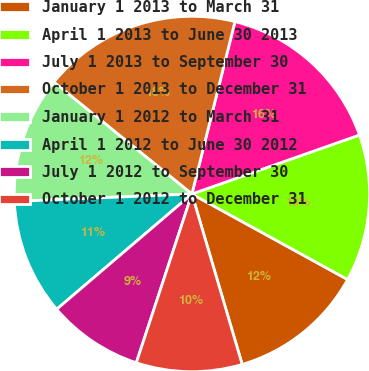Convert chart to OTSL. <chart><loc_0><loc_0><loc_500><loc_500><pie_chart><fcel>January 1 2013 to March 31<fcel>April 1 2013 to June 30 2013<fcel>July 1 2013 to September 30<fcel>October 1 2013 to December 31<fcel>January 1 2012 to March 31<fcel>April 1 2012 to June 30 2012<fcel>July 1 2012 to September 30<fcel>October 1 2012 to December 31<nl><fcel>12.44%<fcel>13.38%<fcel>15.72%<fcel>18.06%<fcel>11.5%<fcel>10.57%<fcel>8.7%<fcel>9.63%<nl></chart> 